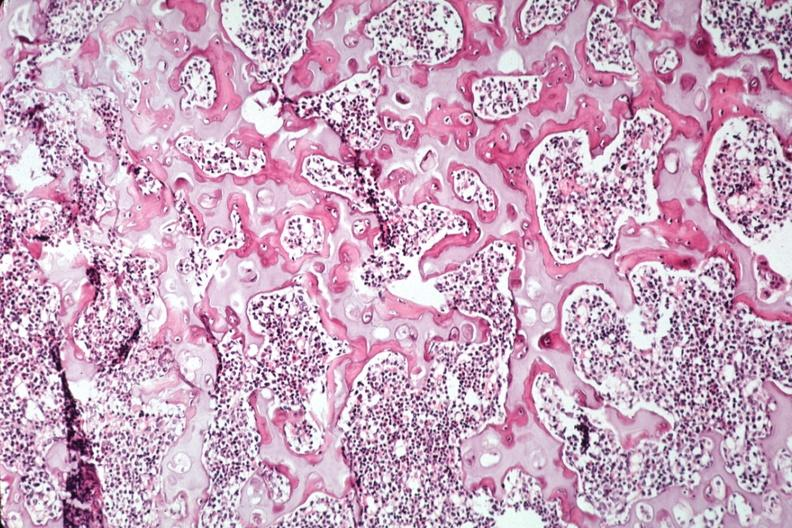what is present?
Answer the question using a single word or phrase. Joints 